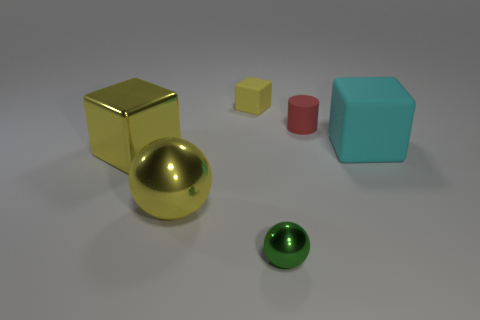There is a rubber object that is behind the red object; is its color the same as the matte block that is to the right of the tiny ball?
Give a very brief answer. No. What number of cyan matte blocks have the same size as the yellow ball?
Give a very brief answer. 1. There is a matte cube that is to the left of the red rubber object; is its size the same as the cylinder?
Your answer should be very brief. Yes. What is the shape of the tiny green object?
Make the answer very short. Sphere. There is another cube that is the same color as the tiny block; what is its size?
Offer a terse response. Large. Does the large yellow thing behind the big yellow sphere have the same material as the small red thing?
Your answer should be very brief. No. Are there any other small shiny balls of the same color as the small metallic ball?
Ensure brevity in your answer.  No. There is a large yellow metallic thing to the right of the big yellow cube; does it have the same shape as the big thing on the right side of the tiny cylinder?
Keep it short and to the point. No. Is there a small red cylinder that has the same material as the tiny red thing?
Offer a very short reply. No. How many cyan objects are large things or big shiny spheres?
Your response must be concise. 1. 